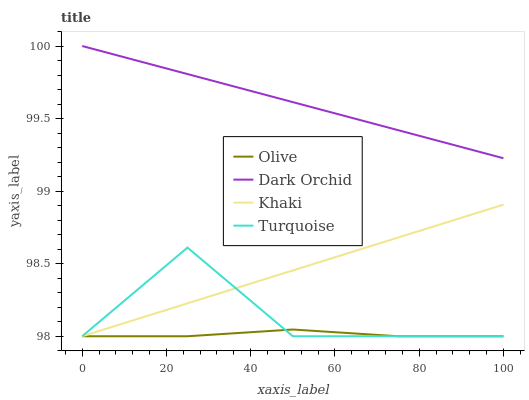Does Olive have the minimum area under the curve?
Answer yes or no. Yes. Does Dark Orchid have the maximum area under the curve?
Answer yes or no. Yes. Does Turquoise have the minimum area under the curve?
Answer yes or no. No. Does Turquoise have the maximum area under the curve?
Answer yes or no. No. Is Khaki the smoothest?
Answer yes or no. Yes. Is Turquoise the roughest?
Answer yes or no. Yes. Is Turquoise the smoothest?
Answer yes or no. No. Is Khaki the roughest?
Answer yes or no. No. Does Olive have the lowest value?
Answer yes or no. Yes. Does Dark Orchid have the lowest value?
Answer yes or no. No. Does Dark Orchid have the highest value?
Answer yes or no. Yes. Does Turquoise have the highest value?
Answer yes or no. No. Is Turquoise less than Dark Orchid?
Answer yes or no. Yes. Is Dark Orchid greater than Turquoise?
Answer yes or no. Yes. Does Olive intersect Turquoise?
Answer yes or no. Yes. Is Olive less than Turquoise?
Answer yes or no. No. Is Olive greater than Turquoise?
Answer yes or no. No. Does Turquoise intersect Dark Orchid?
Answer yes or no. No. 